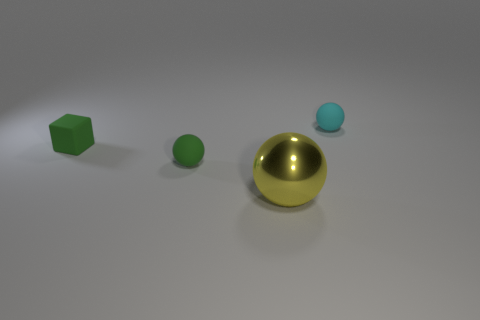Add 3 matte spheres. How many objects exist? 7 Subtract all spheres. How many objects are left? 1 Add 4 tiny spheres. How many tiny spheres exist? 6 Subtract 0 brown balls. How many objects are left? 4 Subtract all big green balls. Subtract all small cyan spheres. How many objects are left? 3 Add 4 large metallic balls. How many large metallic balls are left? 5 